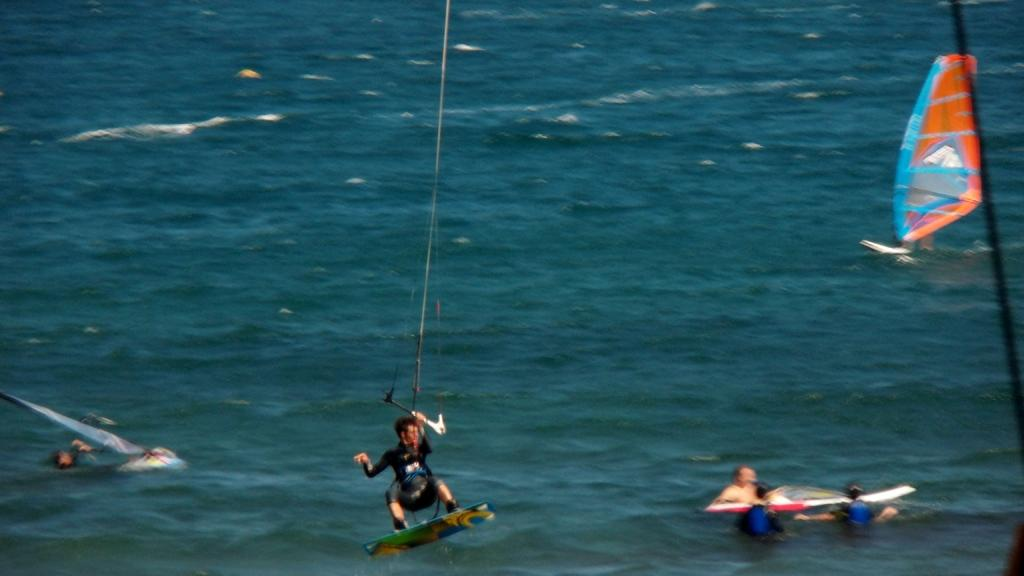What is the person in the image doing on the water? The person is using a ski board on the water. What is the person holding while on the water? The person is holding a stick. Are there any other people visible in the image? Yes, there are other people on the water. What are the other people doing in the image? The other people are holding a boat. How many clocks can be seen on the boat in the image? There are no clocks visible in the image, as the focus is on the people and their activities on the water. 